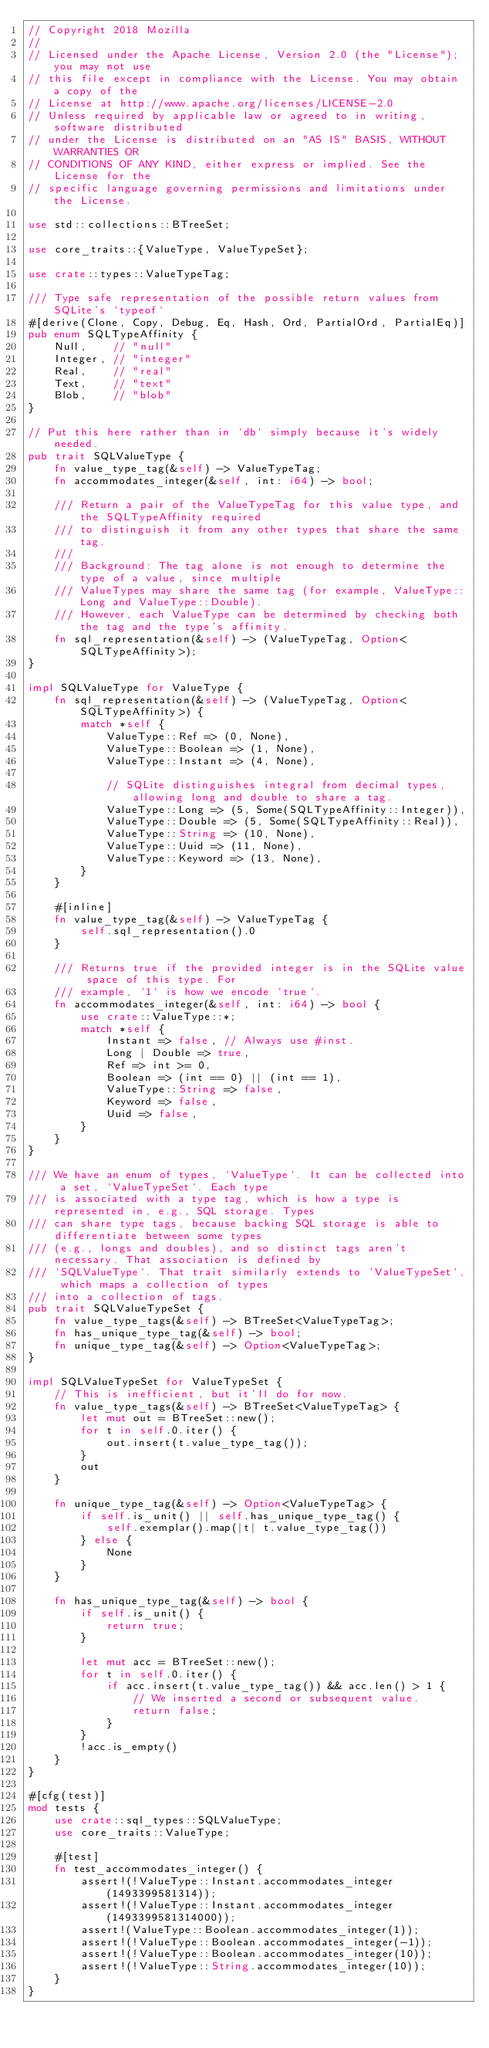Convert code to text. <code><loc_0><loc_0><loc_500><loc_500><_Rust_>// Copyright 2018 Mozilla
//
// Licensed under the Apache License, Version 2.0 (the "License"); you may not use
// this file except in compliance with the License. You may obtain a copy of the
// License at http://www.apache.org/licenses/LICENSE-2.0
// Unless required by applicable law or agreed to in writing, software distributed
// under the License is distributed on an "AS IS" BASIS, WITHOUT WARRANTIES OR
// CONDITIONS OF ANY KIND, either express or implied. See the License for the
// specific language governing permissions and limitations under the License.

use std::collections::BTreeSet;

use core_traits::{ValueType, ValueTypeSet};

use crate::types::ValueTypeTag;

/// Type safe representation of the possible return values from SQLite's `typeof`
#[derive(Clone, Copy, Debug, Eq, Hash, Ord, PartialOrd, PartialEq)]
pub enum SQLTypeAffinity {
    Null,    // "null"
    Integer, // "integer"
    Real,    // "real"
    Text,    // "text"
    Blob,    // "blob"
}

// Put this here rather than in `db` simply because it's widely needed.
pub trait SQLValueType {
    fn value_type_tag(&self) -> ValueTypeTag;
    fn accommodates_integer(&self, int: i64) -> bool;

    /// Return a pair of the ValueTypeTag for this value type, and the SQLTypeAffinity required
    /// to distinguish it from any other types that share the same tag.
    ///
    /// Background: The tag alone is not enough to determine the type of a value, since multiple
    /// ValueTypes may share the same tag (for example, ValueType::Long and ValueType::Double).
    /// However, each ValueType can be determined by checking both the tag and the type's affinity.
    fn sql_representation(&self) -> (ValueTypeTag, Option<SQLTypeAffinity>);
}

impl SQLValueType for ValueType {
    fn sql_representation(&self) -> (ValueTypeTag, Option<SQLTypeAffinity>) {
        match *self {
            ValueType::Ref => (0, None),
            ValueType::Boolean => (1, None),
            ValueType::Instant => (4, None),

            // SQLite distinguishes integral from decimal types, allowing long and double to share a tag.
            ValueType::Long => (5, Some(SQLTypeAffinity::Integer)),
            ValueType::Double => (5, Some(SQLTypeAffinity::Real)),
            ValueType::String => (10, None),
            ValueType::Uuid => (11, None),
            ValueType::Keyword => (13, None),
        }
    }

    #[inline]
    fn value_type_tag(&self) -> ValueTypeTag {
        self.sql_representation().0
    }

    /// Returns true if the provided integer is in the SQLite value space of this type. For
    /// example, `1` is how we encode `true`.
    fn accommodates_integer(&self, int: i64) -> bool {
        use crate::ValueType::*;
        match *self {
            Instant => false, // Always use #inst.
            Long | Double => true,
            Ref => int >= 0,
            Boolean => (int == 0) || (int == 1),
            ValueType::String => false,
            Keyword => false,
            Uuid => false,
        }
    }
}

/// We have an enum of types, `ValueType`. It can be collected into a set, `ValueTypeSet`. Each type
/// is associated with a type tag, which is how a type is represented in, e.g., SQL storage. Types
/// can share type tags, because backing SQL storage is able to differentiate between some types
/// (e.g., longs and doubles), and so distinct tags aren't necessary. That association is defined by
/// `SQLValueType`. That trait similarly extends to `ValueTypeSet`, which maps a collection of types
/// into a collection of tags.
pub trait SQLValueTypeSet {
    fn value_type_tags(&self) -> BTreeSet<ValueTypeTag>;
    fn has_unique_type_tag(&self) -> bool;
    fn unique_type_tag(&self) -> Option<ValueTypeTag>;
}

impl SQLValueTypeSet for ValueTypeSet {
    // This is inefficient, but it'll do for now.
    fn value_type_tags(&self) -> BTreeSet<ValueTypeTag> {
        let mut out = BTreeSet::new();
        for t in self.0.iter() {
            out.insert(t.value_type_tag());
        }
        out
    }

    fn unique_type_tag(&self) -> Option<ValueTypeTag> {
        if self.is_unit() || self.has_unique_type_tag() {
            self.exemplar().map(|t| t.value_type_tag())
        } else {
            None
        }
    }

    fn has_unique_type_tag(&self) -> bool {
        if self.is_unit() {
            return true;
        }

        let mut acc = BTreeSet::new();
        for t in self.0.iter() {
            if acc.insert(t.value_type_tag()) && acc.len() > 1 {
                // We inserted a second or subsequent value.
                return false;
            }
        }
        !acc.is_empty()
    }
}

#[cfg(test)]
mod tests {
    use crate::sql_types::SQLValueType;
    use core_traits::ValueType;

    #[test]
    fn test_accommodates_integer() {
        assert!(!ValueType::Instant.accommodates_integer(1493399581314));
        assert!(!ValueType::Instant.accommodates_integer(1493399581314000));
        assert!(ValueType::Boolean.accommodates_integer(1));
        assert!(!ValueType::Boolean.accommodates_integer(-1));
        assert!(!ValueType::Boolean.accommodates_integer(10));
        assert!(!ValueType::String.accommodates_integer(10));
    }
}
</code> 